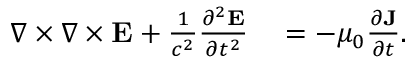<formula> <loc_0><loc_0><loc_500><loc_500>\begin{array} { r l } { \nabla \times \nabla \times { \mathbf E } + \frac { 1 } { c ^ { 2 } } \frac { \partial ^ { 2 } { \mathbf E } } { \partial t ^ { 2 } } } & = - \mu _ { 0 } \frac { \partial { \mathbf J } } { \partial t } . } \end{array}</formula> 